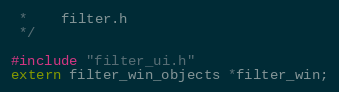<code> <loc_0><loc_0><loc_500><loc_500><_C_> *	filter.h
 */

#include "filter_ui.h"
extern filter_win_objects *filter_win;
</code> 